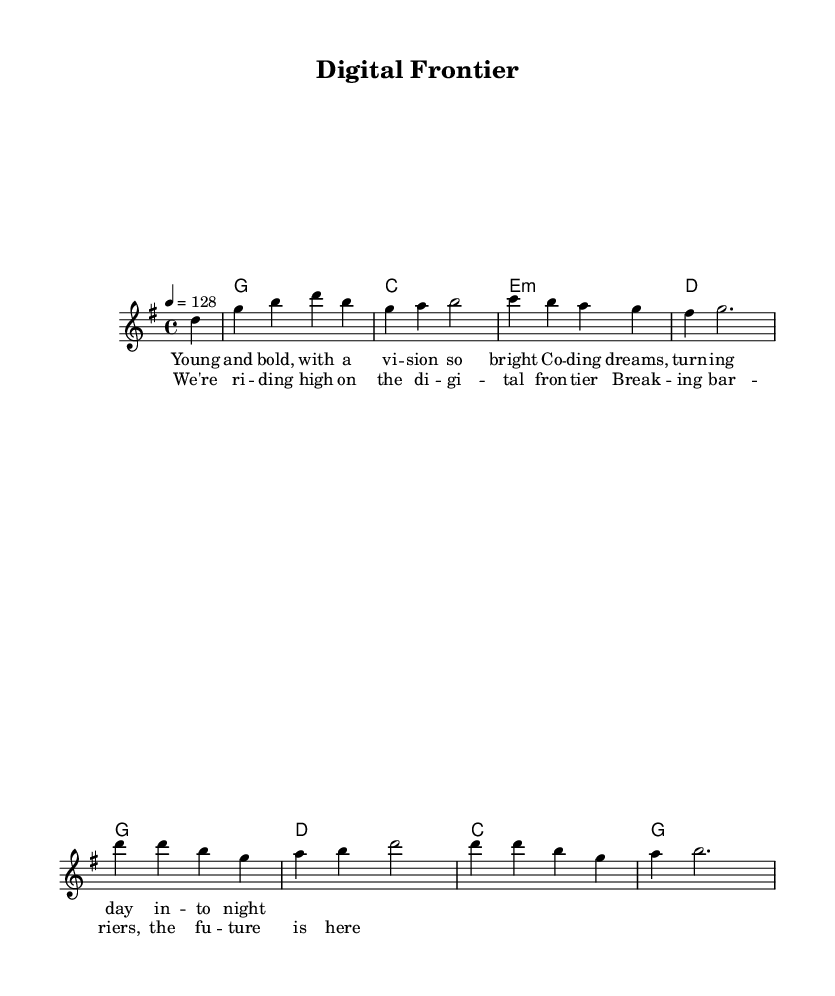What is the key signature of this music? The key signature shown at the beginning of the score indicates G major, which has one sharp (F#).
Answer: G major What is the time signature of this music? The time signature is indicated at the start as 4/4, meaning there are four beats in each measure and a quarter note receives one beat.
Answer: 4/4 What is the tempo marking for this piece? The tempo marking states "4 = 128," indicating that there are 128 beats per minute.
Answer: 128 How many measures are in the melody section? Counting the measures displayed in the melody, there are a total of eight measures depicted in this segment.
Answer: Eight What is the chord progression used in the verse? The chord progression alternates through several chords: G, C, E minor, and D, providing harmonic support for the melody in the verse.
Answer: G, C, E minor, D Which lyrical theme is represented in the chorus? The chorus emphasizes themes of success and innovation, particularly focusing on the achievement and future prospects of digital advancements.
Answer: Success and innovation Which musical genre best describes this piece? This music incorporates elements typical of country rock, characterized by upbeat rhythms and themes of entrepreneurship, making it distinctly identifiable as such.
Answer: Country rock 